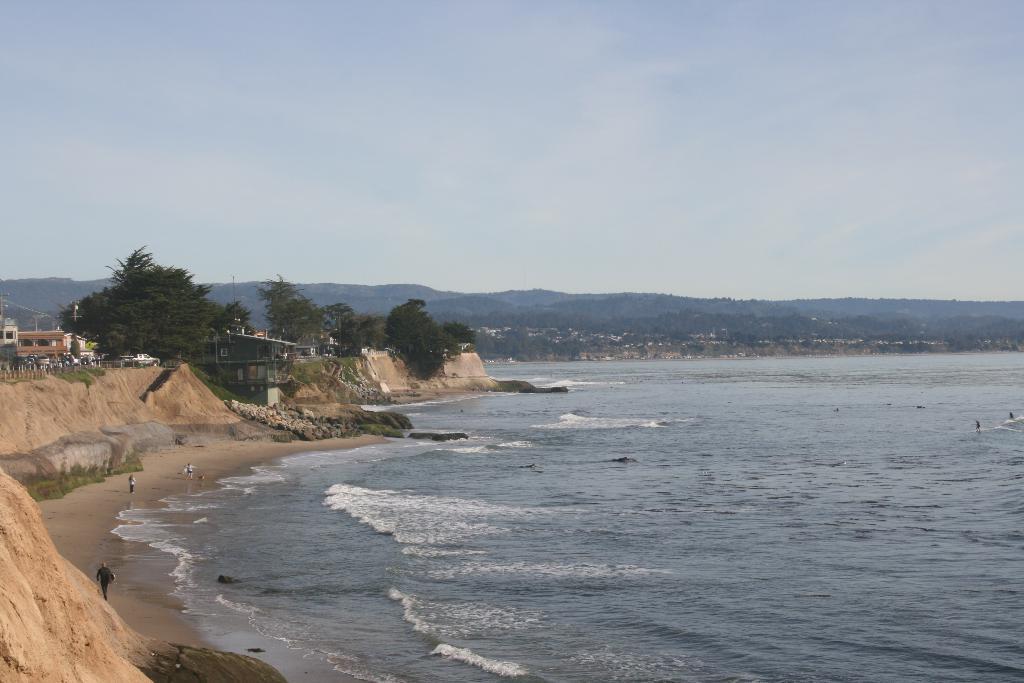Please provide a concise description of this image. This image is taken outdoors. At the top of the image there is a sky with clouds. On the right side of the image there is a sea with waves. In the background there are a few hills and there are many trees and plants. On the left side of the image there are a few houses and trees on the hill and a few people are walking on the ground. 